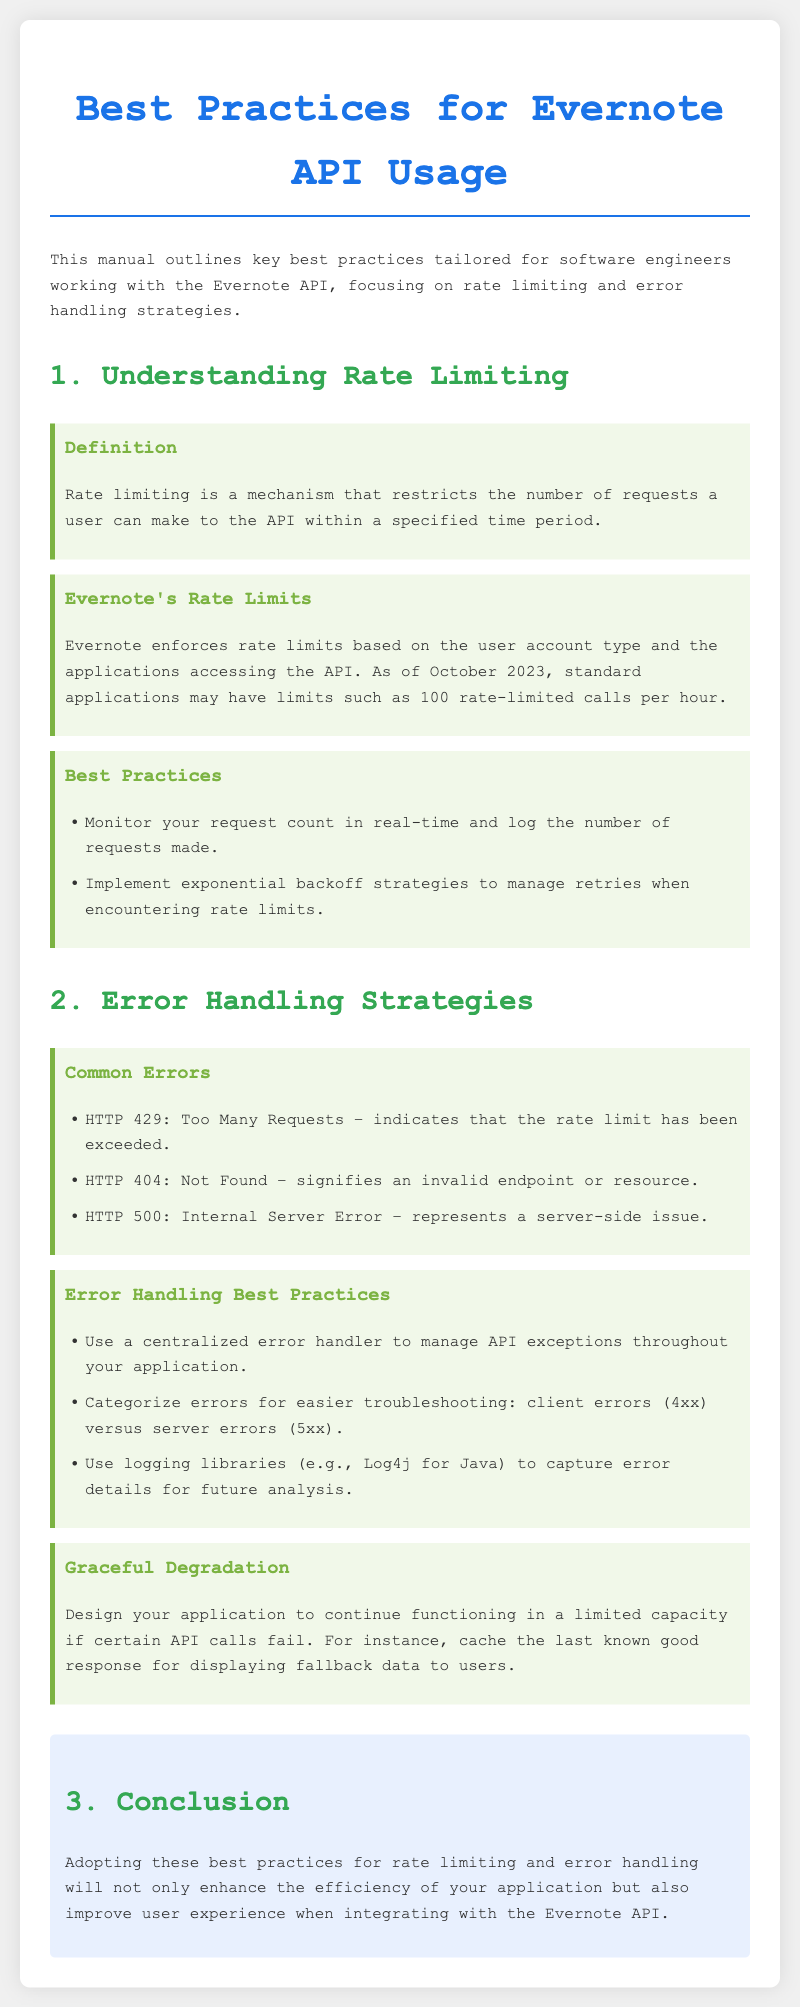What is rate limiting? Rate limiting is defined as a mechanism that restricts the number of requests a user can make to the API within a specified time period.
Answer: a mechanism that restricts the number of requests What is the rate limit for standard applications in Evernote as of October 2023? The document states that standard applications may have limits such as 100 rate-limited calls per hour.
Answer: 100 rate-limited calls per hour What should be used to manage retries when encountering rate limits? The document mentions implementing exponential backoff strategies to manage retries when encountering rate limits.
Answer: exponential backoff strategies Which HTTP status code indicates a server-side issue? The document lists HTTP 500 as indicating a server-side issue.
Answer: HTTP 500 What is one recommended practice for error handling? The document recommends using a centralized error handler to manage API exceptions throughout your application.
Answer: centralized error handler What is graceful degradation? Graceful degradation is defined as designing your application to continue functioning in a limited capacity if certain API calls fail.
Answer: continue functioning in a limited capacity How are errors categorized for easier troubleshooting? The document states that errors should be categorized into client errors (4xx) versus server errors (5xx).
Answer: client errors (4xx) versus server errors (5xx) What is a common response to an invalid endpoint? The document states that HTTP 404 signifies an invalid endpoint.
Answer: HTTP 404 